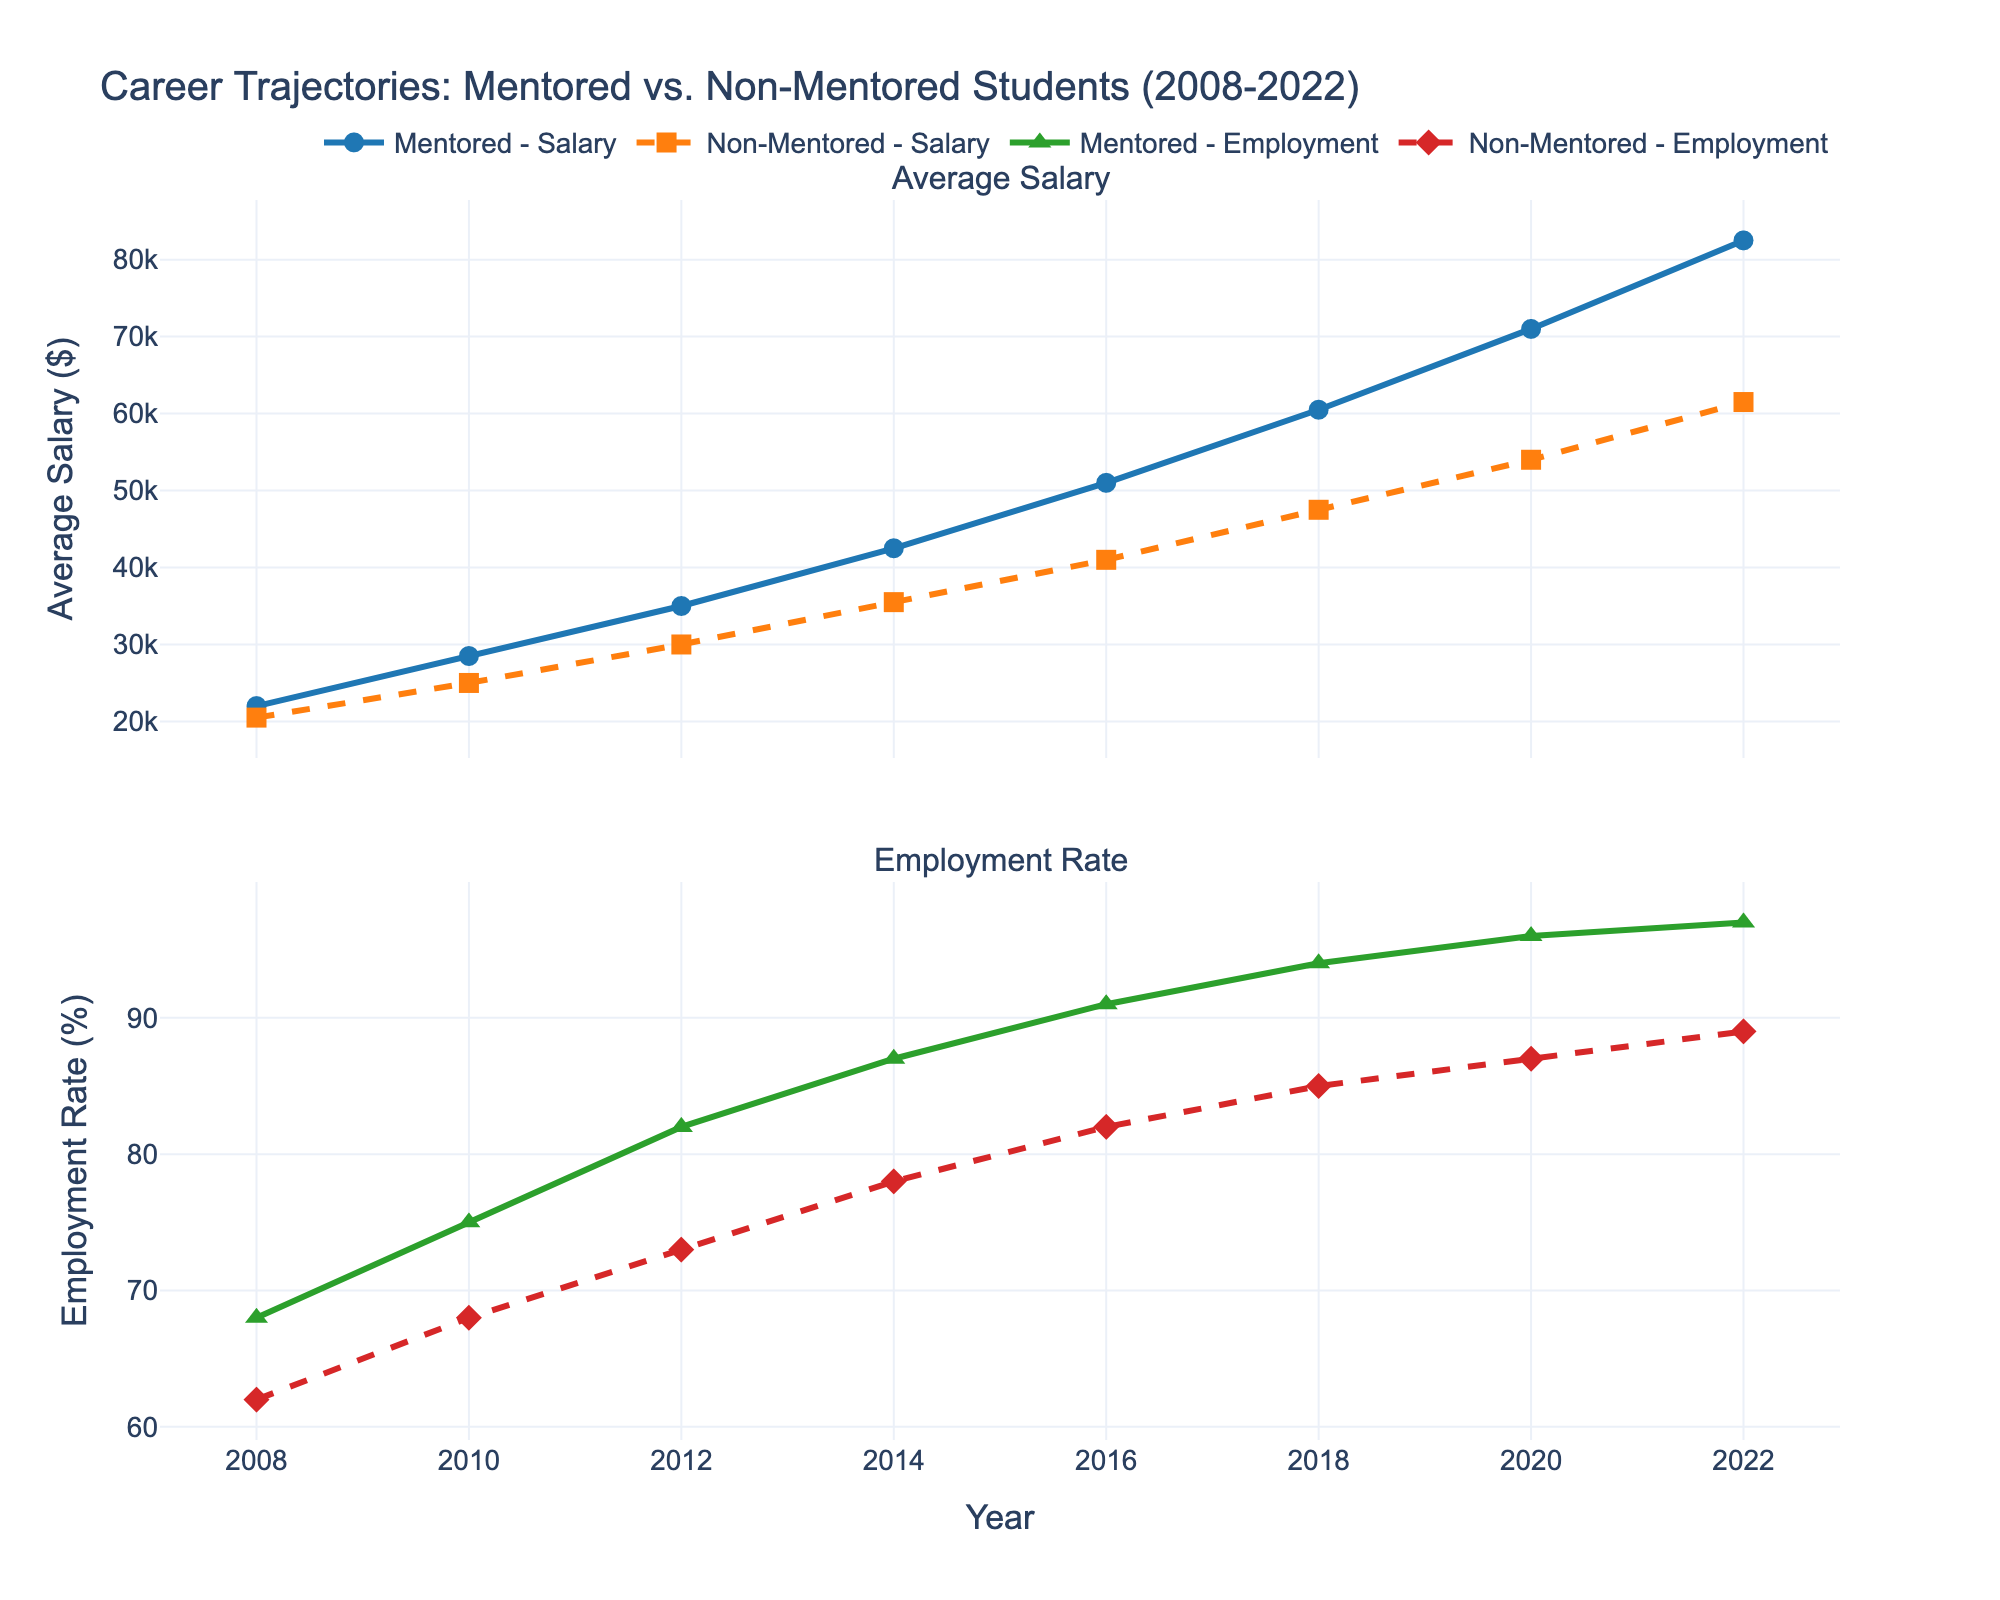What was the average salary for mentored students in 2016? Looking at the first subplot labeled "Average Salary," find the line representing mentored students (solid blue). Trace to the year 2016, and the y-axis value is 51000.
Answer: 51000 In which year did mentored students first surpass a 90% employment rate? Check the second subplot labeled "Employment Rate," find the line for mentored students (solid green). The employment rate surpasses 90% in 2016.
Answer: 2016 Which group had a higher average salary in 2010, and by how much? Compare the two lines in the first subplot for the year 2010. Mentored students had an average salary of 28500, while non-mentored students had 25000. The difference is 28500 - 25000 = 3500.
Answer: Mentored Students, 3500 What is the trend in employment rates for non-mentored students from 2008 to 2022? Focus on the dashed red line in the second subplot. Visually assess whether it generally increases, decreases, or stays level. The trend shows a general increase from 62% to 89%.
Answer: Increasing By how much did the average salary for mentored students increase from 2008 to 2022? Find the initial value for 2008 and the final value for 2022 for the blue line in the first subplot. The calculation is 82500 - 22000 = 60500.
Answer: 60500 In what year is the gap between mentored and non-mentored average salaries the largest? Compare the vertical distance between the two lines in the first subplot for each year. The largest gap visually is around 2022.
Answer: 2022 How many years did it take for the employment rate of non-mentored students to reach 87%? Look at the dashed red line in the second subplot and check when it hits 87%; it initially hits this rate in 2020. Since the starting year is 2008, it took 2020 - 2008 = 12 years.
Answer: 12 years What is the employment rate for mentored students in 2018? Locate 2018 on the x-axis of the second subplot and follow it up to the solid green line. The y-axis value is 94%.
Answer: 94% What is the average employment rate for mentored students between 2008 and 2022? List and sum all the employment rates for mentored students: 68, 75, 82, 87, 91, 94, 96, 97. The sum is 590. There are 8 data points, so the average is 590 / 8 = 73.75%.
Answer: 73.75% 